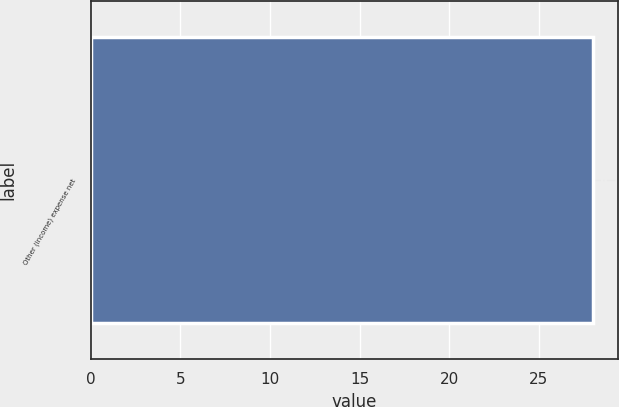<chart> <loc_0><loc_0><loc_500><loc_500><bar_chart><fcel>Other (income) expense net<nl><fcel>28<nl></chart> 